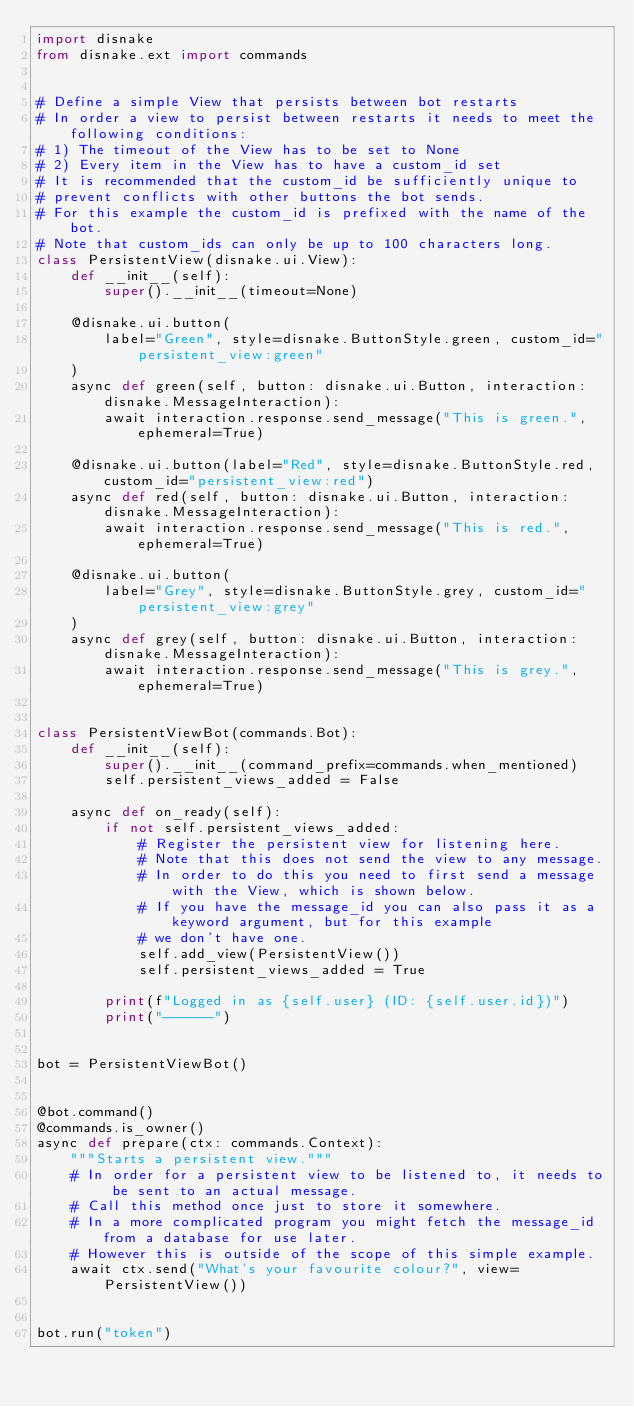Convert code to text. <code><loc_0><loc_0><loc_500><loc_500><_Python_>import disnake
from disnake.ext import commands


# Define a simple View that persists between bot restarts
# In order a view to persist between restarts it needs to meet the following conditions:
# 1) The timeout of the View has to be set to None
# 2) Every item in the View has to have a custom_id set
# It is recommended that the custom_id be sufficiently unique to
# prevent conflicts with other buttons the bot sends.
# For this example the custom_id is prefixed with the name of the bot.
# Note that custom_ids can only be up to 100 characters long.
class PersistentView(disnake.ui.View):
    def __init__(self):
        super().__init__(timeout=None)

    @disnake.ui.button(
        label="Green", style=disnake.ButtonStyle.green, custom_id="persistent_view:green"
    )
    async def green(self, button: disnake.ui.Button, interaction: disnake.MessageInteraction):
        await interaction.response.send_message("This is green.", ephemeral=True)

    @disnake.ui.button(label="Red", style=disnake.ButtonStyle.red, custom_id="persistent_view:red")
    async def red(self, button: disnake.ui.Button, interaction: disnake.MessageInteraction):
        await interaction.response.send_message("This is red.", ephemeral=True)

    @disnake.ui.button(
        label="Grey", style=disnake.ButtonStyle.grey, custom_id="persistent_view:grey"
    )
    async def grey(self, button: disnake.ui.Button, interaction: disnake.MessageInteraction):
        await interaction.response.send_message("This is grey.", ephemeral=True)


class PersistentViewBot(commands.Bot):
    def __init__(self):
        super().__init__(command_prefix=commands.when_mentioned)
        self.persistent_views_added = False

    async def on_ready(self):
        if not self.persistent_views_added:
            # Register the persistent view for listening here.
            # Note that this does not send the view to any message.
            # In order to do this you need to first send a message with the View, which is shown below.
            # If you have the message_id you can also pass it as a keyword argument, but for this example
            # we don't have one.
            self.add_view(PersistentView())
            self.persistent_views_added = True

        print(f"Logged in as {self.user} (ID: {self.user.id})")
        print("------")


bot = PersistentViewBot()


@bot.command()
@commands.is_owner()
async def prepare(ctx: commands.Context):
    """Starts a persistent view."""
    # In order for a persistent view to be listened to, it needs to be sent to an actual message.
    # Call this method once just to store it somewhere.
    # In a more complicated program you might fetch the message_id from a database for use later.
    # However this is outside of the scope of this simple example.
    await ctx.send("What's your favourite colour?", view=PersistentView())


bot.run("token")
</code> 